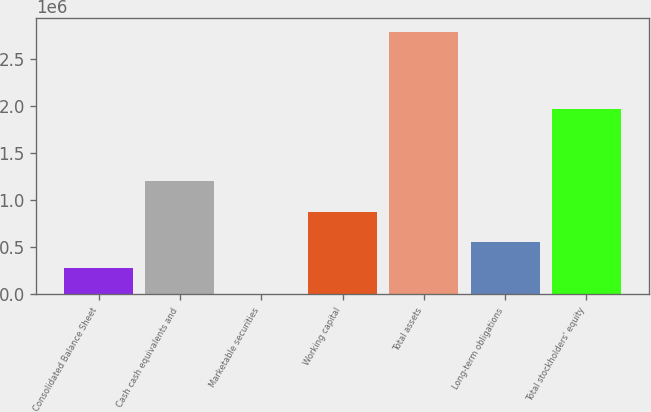Convert chart to OTSL. <chart><loc_0><loc_0><loc_500><loc_500><bar_chart><fcel>Consolidated Balance Sheet<fcel>Cash cash equivalents and<fcel>Marketable securities<fcel>Working capital<fcel>Total assets<fcel>Long-term obligations<fcel>Total stockholders' equity<nl><fcel>279805<fcel>1.2068e+06<fcel>865<fcel>872705<fcel>2.79027e+06<fcel>558745<fcel>1.96484e+06<nl></chart> 